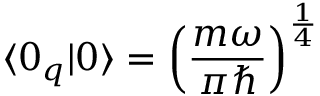Convert formula to latex. <formula><loc_0><loc_0><loc_500><loc_500>\langle 0 _ { q } | 0 \rangle = \left ( \frac { m \omega } { \pi } \right ) ^ { \frac { 1 } { 4 } }</formula> 